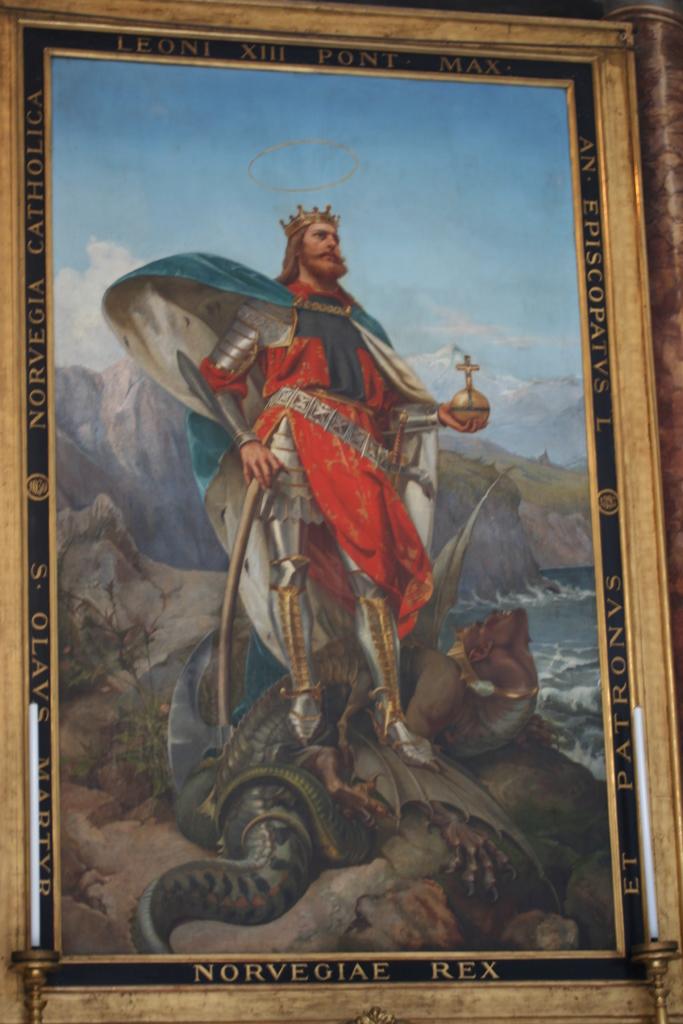What does the frame of the painting say?
Offer a very short reply. Norvegiae rex. Is this a painting of rex?
Give a very brief answer. Yes. 